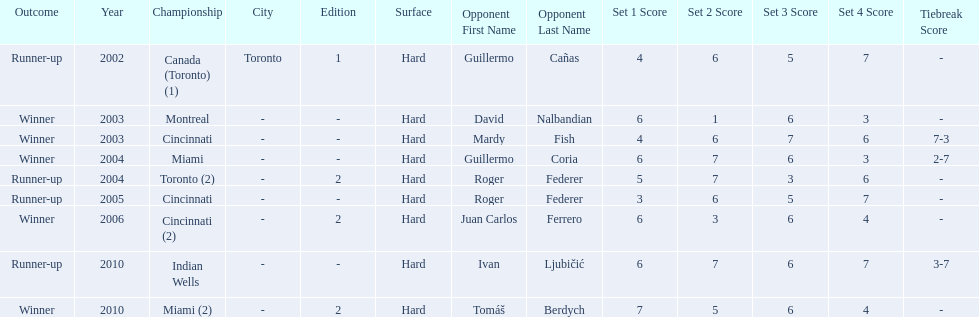I'm looking to parse the entire table for insights. Could you assist me with that? {'header': ['Outcome', 'Year', 'Championship', 'City', 'Edition', 'Surface', 'Opponent First Name', 'Opponent Last Name', 'Set 1 Score', 'Set 2 Score', 'Set 3 Score', 'Set 4 Score', 'Tiebreak Score'], 'rows': [['Runner-up', '2002', 'Canada (Toronto) (1)', 'Toronto', '1', 'Hard', 'Guillermo', 'Cañas', '4', '6', '5', '7', '-'], ['Winner', '2003', 'Montreal', '-', '-', 'Hard', 'David', 'Nalbandian', '6', '1', '6', '3', '-'], ['Winner', '2003', 'Cincinnati', '-', '-', 'Hard', 'Mardy', 'Fish', '4', '6', '7', '6', '7-3'], ['Winner', '2004', 'Miami', '-', '-', 'Hard', 'Guillermo', 'Coria', '6', '7', '6', '3', '2-7'], ['Runner-up', '2004', 'Toronto (2)', '-', '2', 'Hard', 'Roger', 'Federer', '5', '7', '3', '6', '-'], ['Runner-up', '2005', 'Cincinnati', '-', '-', 'Hard', 'Roger', 'Federer', '3', '6', '5', '7', '-'], ['Winner', '2006', 'Cincinnati (2)', '-', '2', 'Hard', 'Juan Carlos', 'Ferrero', '6', '3', '6', '4', '-'], ['Runner-up', '2010', 'Indian Wells', '-', '-', 'Hard', 'Ivan', 'Ljubičić', '6', '7', '6', '7', '3-7'], ['Winner', '2010', 'Miami (2)', '-', '2', 'Hard', 'Tomáš', 'Berdych', '7', '5', '6', '4', '-']]} How many times has he been runner-up? 4. 